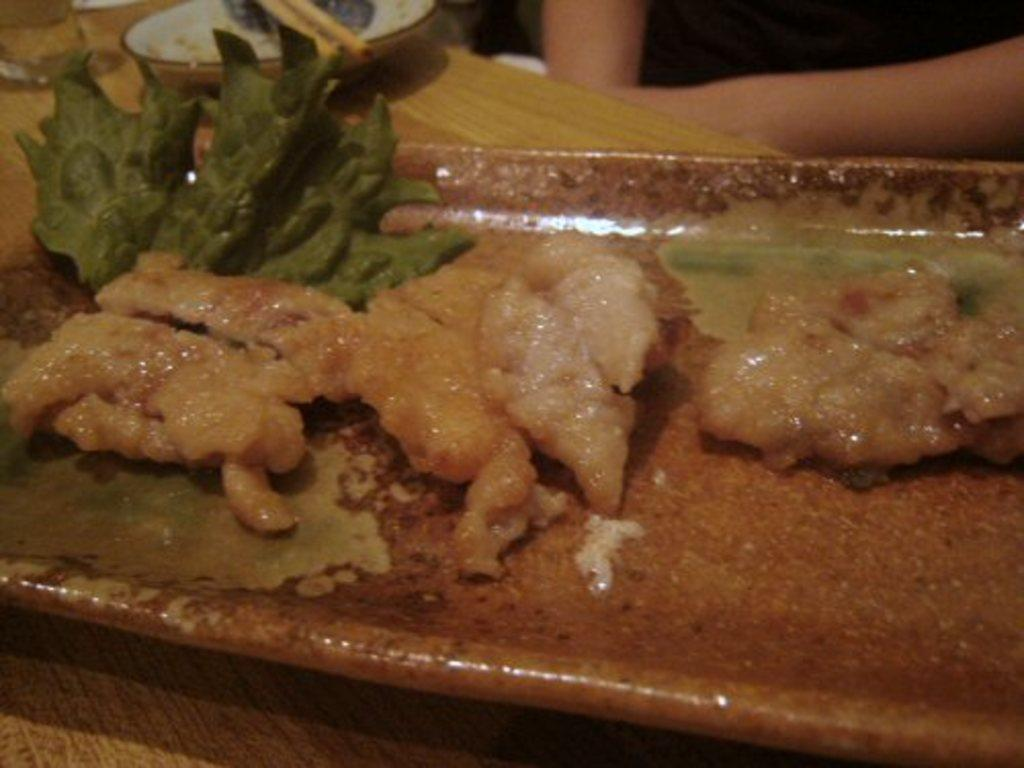What is on the plate in the image? There is food served on a plate in the image. What utensils are present in the image? There are two chopsticks on a saucer in the image. Can you describe the person in the image? The image shows a person sitting in front of the table. What type of secretary is sitting next to the person in the image? There is no secretary present in the image. What type of jeans is the person wearing in the image? The image does not show the person's clothing, so it cannot be determined if they are wearing jeans. 